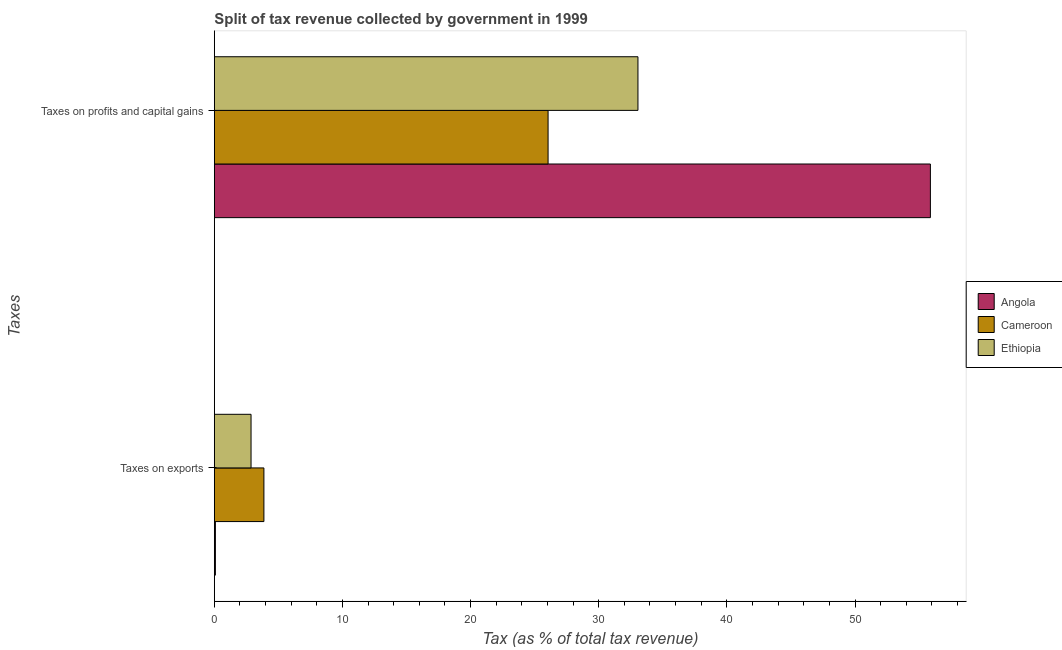Are the number of bars on each tick of the Y-axis equal?
Ensure brevity in your answer.  Yes. How many bars are there on the 1st tick from the bottom?
Provide a short and direct response. 3. What is the label of the 2nd group of bars from the top?
Keep it short and to the point. Taxes on exports. What is the percentage of revenue obtained from taxes on exports in Ethiopia?
Give a very brief answer. 2.86. Across all countries, what is the maximum percentage of revenue obtained from taxes on profits and capital gains?
Your answer should be compact. 55.88. Across all countries, what is the minimum percentage of revenue obtained from taxes on exports?
Offer a terse response. 0.08. In which country was the percentage of revenue obtained from taxes on profits and capital gains maximum?
Provide a succinct answer. Angola. In which country was the percentage of revenue obtained from taxes on exports minimum?
Make the answer very short. Angola. What is the total percentage of revenue obtained from taxes on profits and capital gains in the graph?
Give a very brief answer. 114.99. What is the difference between the percentage of revenue obtained from taxes on exports in Cameroon and that in Ethiopia?
Your response must be concise. 1. What is the difference between the percentage of revenue obtained from taxes on profits and capital gains in Cameroon and the percentage of revenue obtained from taxes on exports in Ethiopia?
Your response must be concise. 23.18. What is the average percentage of revenue obtained from taxes on exports per country?
Keep it short and to the point. 2.27. What is the difference between the percentage of revenue obtained from taxes on profits and capital gains and percentage of revenue obtained from taxes on exports in Ethiopia?
Make the answer very short. 30.2. What is the ratio of the percentage of revenue obtained from taxes on profits and capital gains in Cameroon to that in Ethiopia?
Ensure brevity in your answer.  0.79. What does the 3rd bar from the top in Taxes on exports represents?
Provide a succinct answer. Angola. What does the 3rd bar from the bottom in Taxes on exports represents?
Make the answer very short. Ethiopia. Does the graph contain any zero values?
Keep it short and to the point. No. Does the graph contain grids?
Give a very brief answer. No. How many legend labels are there?
Keep it short and to the point. 3. What is the title of the graph?
Offer a terse response. Split of tax revenue collected by government in 1999. Does "Marshall Islands" appear as one of the legend labels in the graph?
Offer a terse response. No. What is the label or title of the X-axis?
Offer a terse response. Tax (as % of total tax revenue). What is the label or title of the Y-axis?
Your answer should be very brief. Taxes. What is the Tax (as % of total tax revenue) in Angola in Taxes on exports?
Your answer should be very brief. 0.08. What is the Tax (as % of total tax revenue) of Cameroon in Taxes on exports?
Your answer should be very brief. 3.87. What is the Tax (as % of total tax revenue) in Ethiopia in Taxes on exports?
Provide a succinct answer. 2.86. What is the Tax (as % of total tax revenue) of Angola in Taxes on profits and capital gains?
Your answer should be very brief. 55.88. What is the Tax (as % of total tax revenue) in Cameroon in Taxes on profits and capital gains?
Provide a succinct answer. 26.05. What is the Tax (as % of total tax revenue) in Ethiopia in Taxes on profits and capital gains?
Make the answer very short. 33.06. Across all Taxes, what is the maximum Tax (as % of total tax revenue) in Angola?
Offer a terse response. 55.88. Across all Taxes, what is the maximum Tax (as % of total tax revenue) in Cameroon?
Provide a short and direct response. 26.05. Across all Taxes, what is the maximum Tax (as % of total tax revenue) in Ethiopia?
Keep it short and to the point. 33.06. Across all Taxes, what is the minimum Tax (as % of total tax revenue) in Angola?
Your answer should be very brief. 0.08. Across all Taxes, what is the minimum Tax (as % of total tax revenue) of Cameroon?
Offer a very short reply. 3.87. Across all Taxes, what is the minimum Tax (as % of total tax revenue) in Ethiopia?
Make the answer very short. 2.86. What is the total Tax (as % of total tax revenue) of Angola in the graph?
Your response must be concise. 55.97. What is the total Tax (as % of total tax revenue) of Cameroon in the graph?
Give a very brief answer. 29.91. What is the total Tax (as % of total tax revenue) of Ethiopia in the graph?
Make the answer very short. 35.92. What is the difference between the Tax (as % of total tax revenue) in Angola in Taxes on exports and that in Taxes on profits and capital gains?
Your response must be concise. -55.8. What is the difference between the Tax (as % of total tax revenue) of Cameroon in Taxes on exports and that in Taxes on profits and capital gains?
Your answer should be very brief. -22.18. What is the difference between the Tax (as % of total tax revenue) of Ethiopia in Taxes on exports and that in Taxes on profits and capital gains?
Your response must be concise. -30.2. What is the difference between the Tax (as % of total tax revenue) in Angola in Taxes on exports and the Tax (as % of total tax revenue) in Cameroon in Taxes on profits and capital gains?
Ensure brevity in your answer.  -25.97. What is the difference between the Tax (as % of total tax revenue) in Angola in Taxes on exports and the Tax (as % of total tax revenue) in Ethiopia in Taxes on profits and capital gains?
Keep it short and to the point. -32.98. What is the difference between the Tax (as % of total tax revenue) of Cameroon in Taxes on exports and the Tax (as % of total tax revenue) of Ethiopia in Taxes on profits and capital gains?
Provide a short and direct response. -29.19. What is the average Tax (as % of total tax revenue) of Angola per Taxes?
Make the answer very short. 27.98. What is the average Tax (as % of total tax revenue) in Cameroon per Taxes?
Make the answer very short. 14.96. What is the average Tax (as % of total tax revenue) of Ethiopia per Taxes?
Provide a succinct answer. 17.96. What is the difference between the Tax (as % of total tax revenue) of Angola and Tax (as % of total tax revenue) of Cameroon in Taxes on exports?
Provide a succinct answer. -3.79. What is the difference between the Tax (as % of total tax revenue) of Angola and Tax (as % of total tax revenue) of Ethiopia in Taxes on exports?
Your answer should be very brief. -2.78. What is the difference between the Tax (as % of total tax revenue) of Angola and Tax (as % of total tax revenue) of Cameroon in Taxes on profits and capital gains?
Make the answer very short. 29.84. What is the difference between the Tax (as % of total tax revenue) in Angola and Tax (as % of total tax revenue) in Ethiopia in Taxes on profits and capital gains?
Provide a short and direct response. 22.82. What is the difference between the Tax (as % of total tax revenue) in Cameroon and Tax (as % of total tax revenue) in Ethiopia in Taxes on profits and capital gains?
Your answer should be compact. -7.01. What is the ratio of the Tax (as % of total tax revenue) in Angola in Taxes on exports to that in Taxes on profits and capital gains?
Make the answer very short. 0. What is the ratio of the Tax (as % of total tax revenue) in Cameroon in Taxes on exports to that in Taxes on profits and capital gains?
Make the answer very short. 0.15. What is the ratio of the Tax (as % of total tax revenue) of Ethiopia in Taxes on exports to that in Taxes on profits and capital gains?
Your response must be concise. 0.09. What is the difference between the highest and the second highest Tax (as % of total tax revenue) in Angola?
Your answer should be compact. 55.8. What is the difference between the highest and the second highest Tax (as % of total tax revenue) in Cameroon?
Provide a succinct answer. 22.18. What is the difference between the highest and the second highest Tax (as % of total tax revenue) in Ethiopia?
Ensure brevity in your answer.  30.2. What is the difference between the highest and the lowest Tax (as % of total tax revenue) of Angola?
Your answer should be very brief. 55.8. What is the difference between the highest and the lowest Tax (as % of total tax revenue) in Cameroon?
Your response must be concise. 22.18. What is the difference between the highest and the lowest Tax (as % of total tax revenue) in Ethiopia?
Offer a terse response. 30.2. 